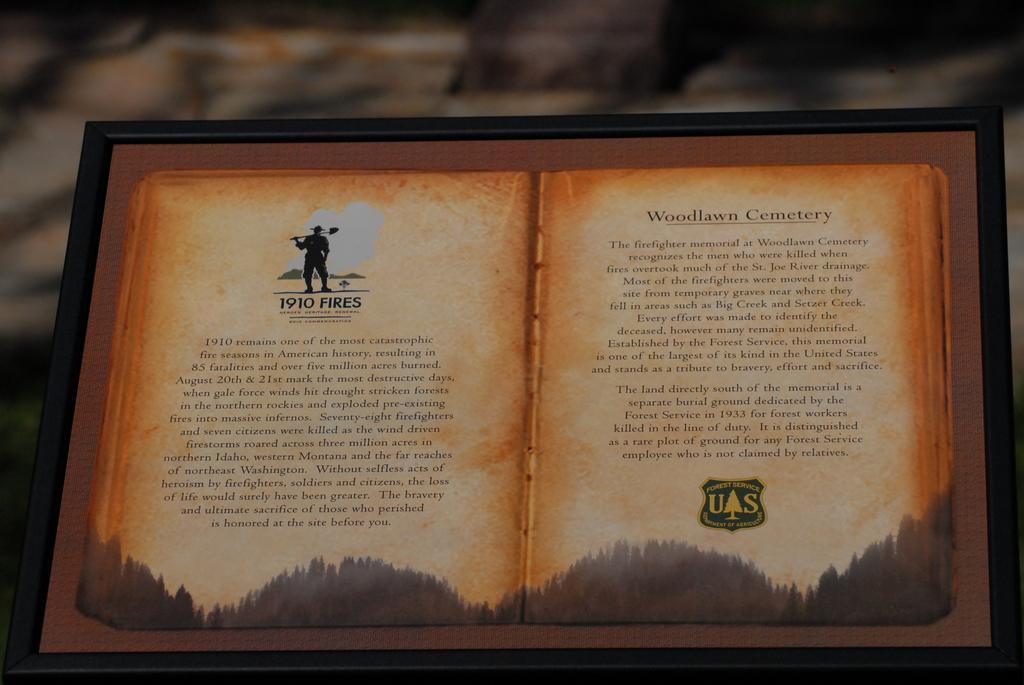What is the main object in the image? The main object in the image is a paper. How is the paper attached to another object? The paper is attached to a wooden board. What is the wooden board's appearance? The wooden board has a black frame. Can you describe the background of the image? The background appears blurry. How does the elbow fit into the battle scene depicted on the paper? There is no battle scene or elbow present in the image; it features a paper attached to a wooden board with a black frame and a blurry background. 